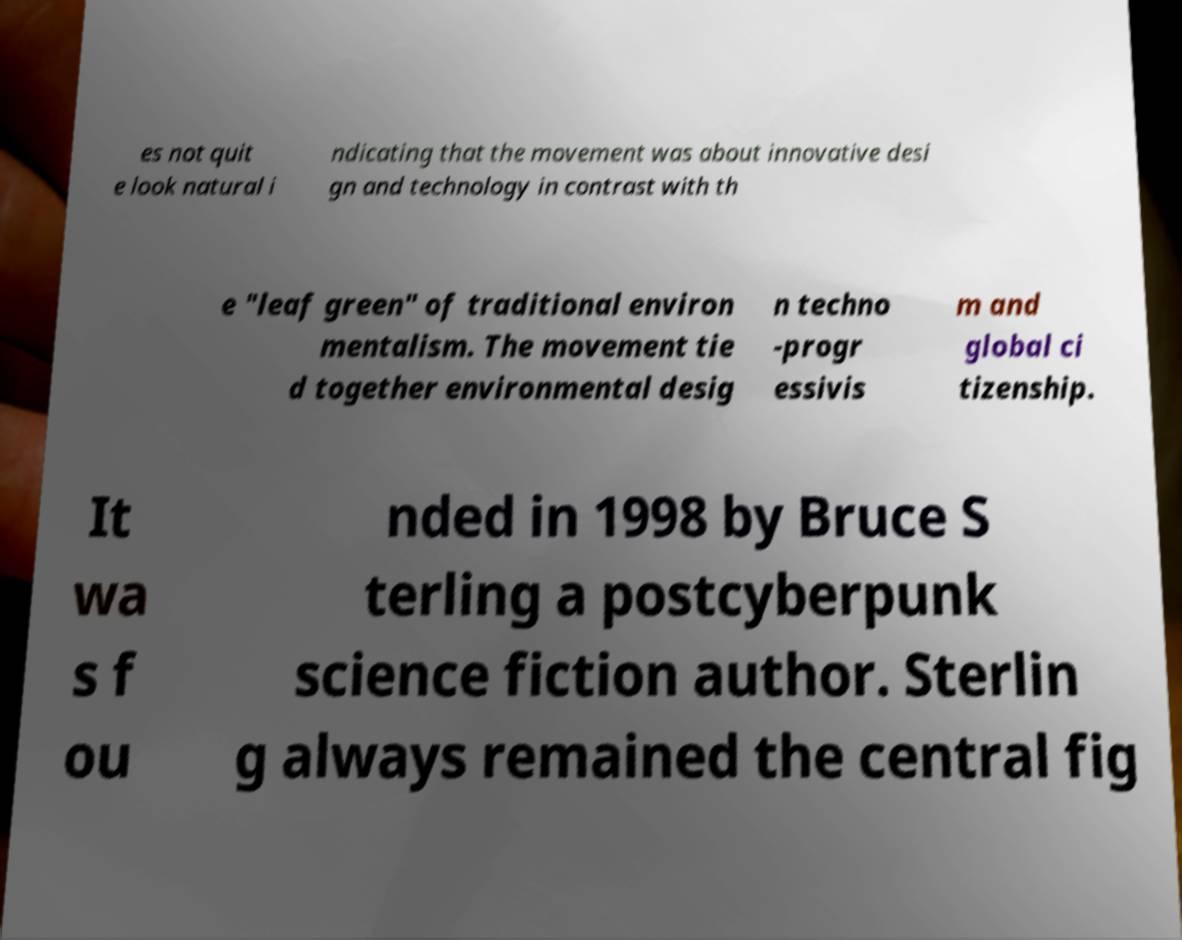Can you read and provide the text displayed in the image?This photo seems to have some interesting text. Can you extract and type it out for me? es not quit e look natural i ndicating that the movement was about innovative desi gn and technology in contrast with th e "leaf green" of traditional environ mentalism. The movement tie d together environmental desig n techno -progr essivis m and global ci tizenship. It wa s f ou nded in 1998 by Bruce S terling a postcyberpunk science fiction author. Sterlin g always remained the central fig 